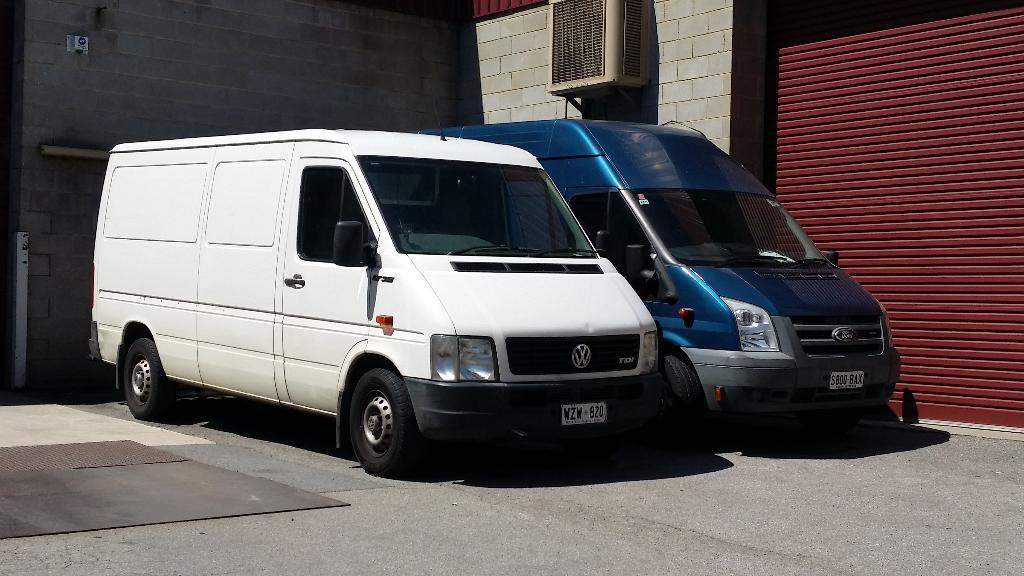What can be seen in the image? There are vehicles in the image. What is visible in the background of the image? There is a brick wall in the background in the image. What is located on the right side of the image? There is a shutter on the right side of the image. What type of object is attached to the wall in the image? There is an electronic device on the wall in the image. What type of club is located near the vehicles in the image? There is no club present in the image; it only features vehicles, a brick wall, a shutter, and an electronic device on the wall. 